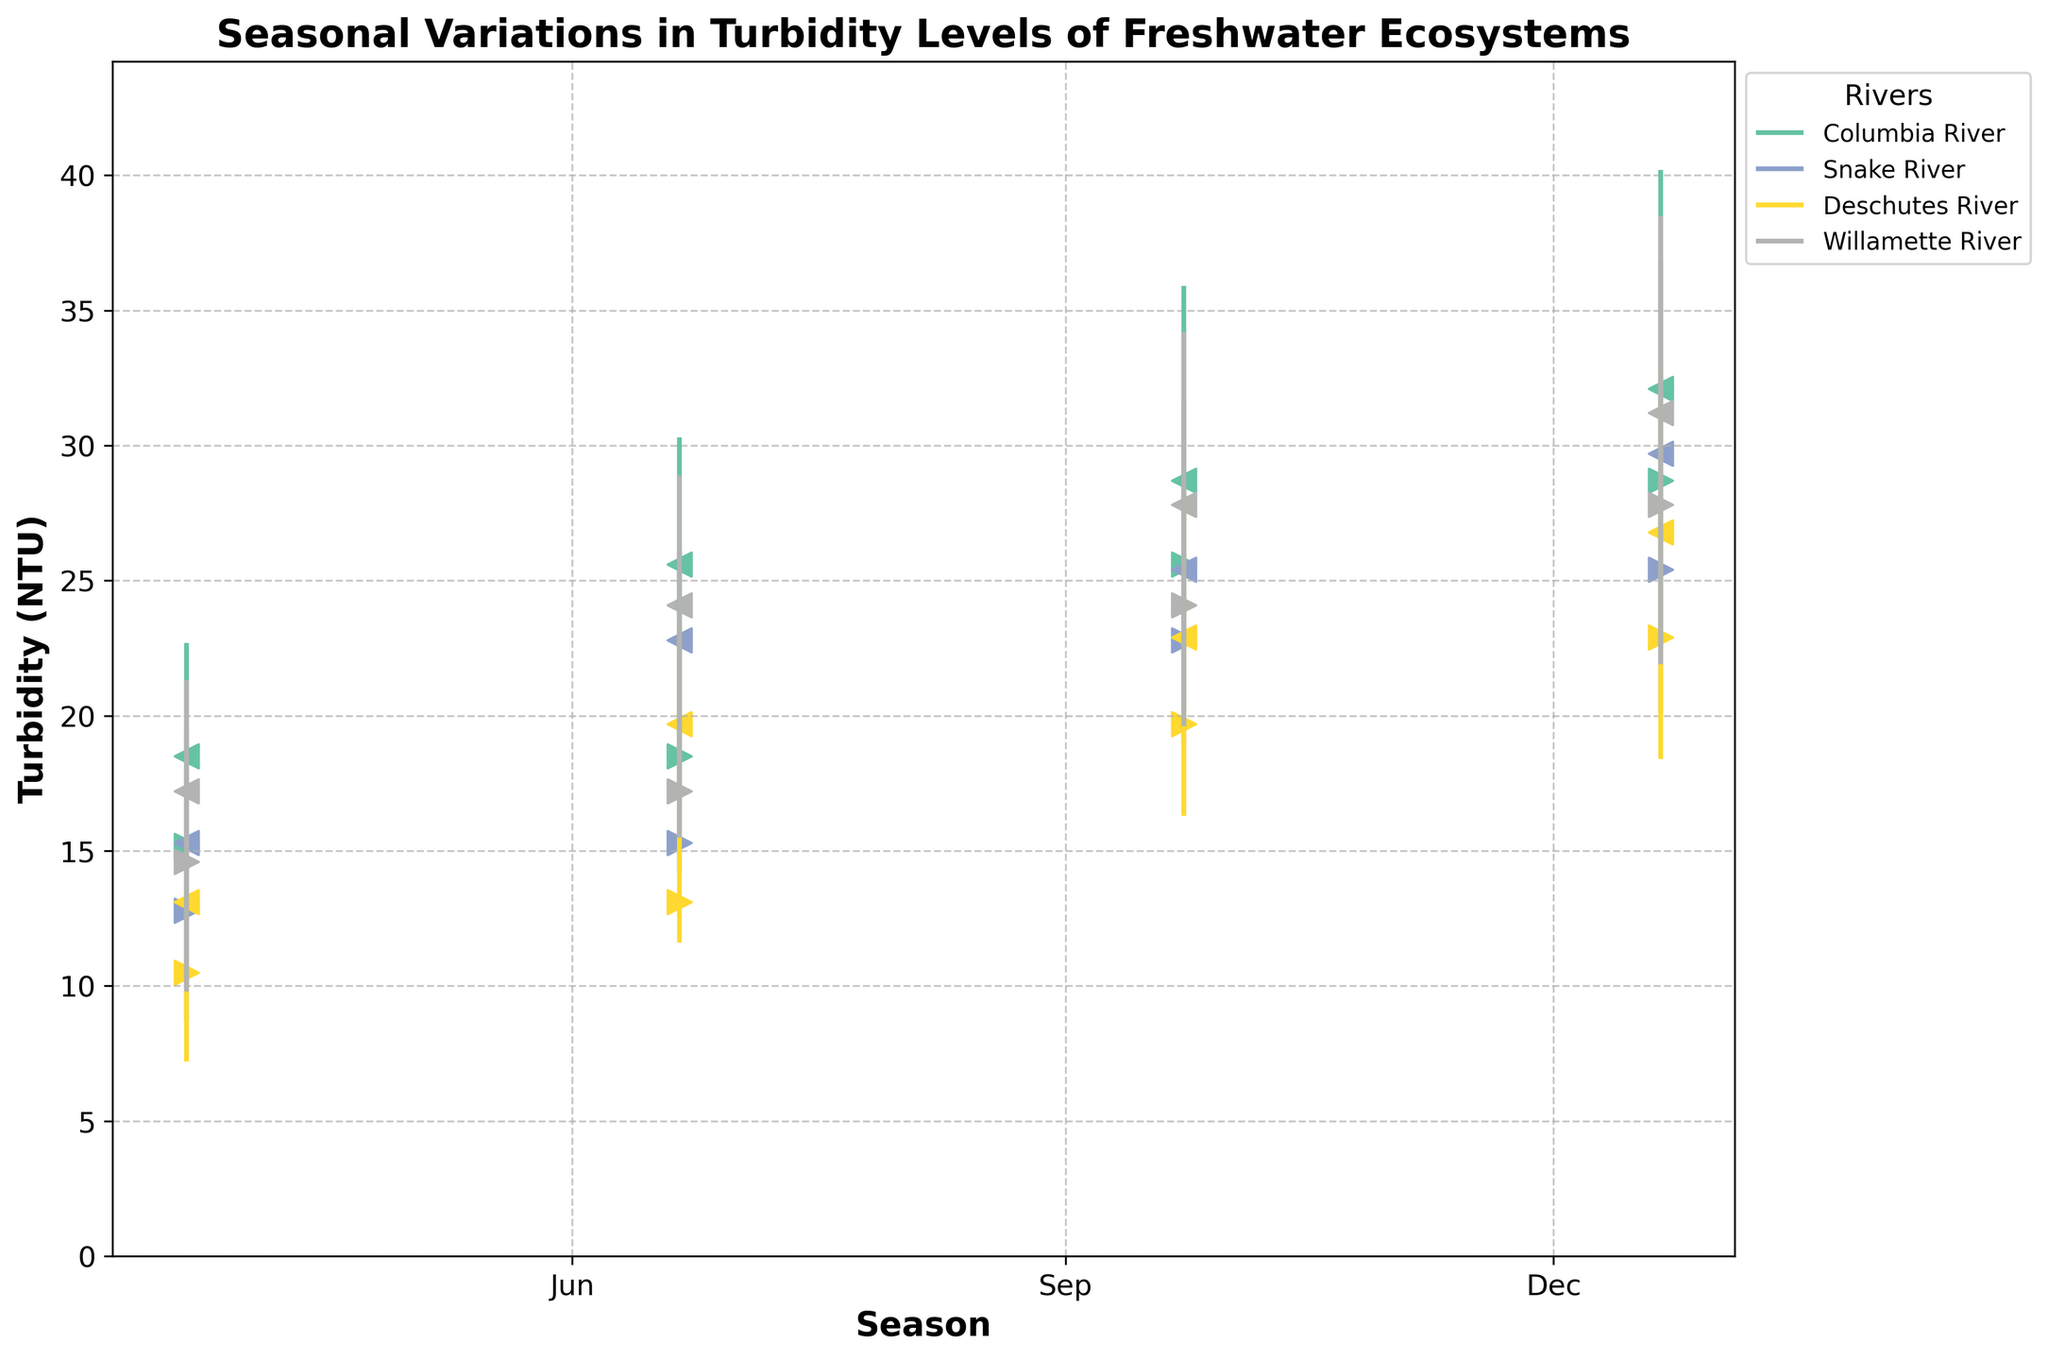What is the title of the figure? The title is displayed at the top of the figure and it is "Seasonal Variations in Turbidity Levels of Freshwater Ecosystems".
Answer: Seasonal Variations in Turbidity Levels of Freshwater Ecosystems How many rivers are represented in the plot? By looking at the legend, we can see the different colors and labels for each river. The figure shows four rivers: Columbia River, Snake River, Deschutes River, and Willamette River.
Answer: Four Which river has the highest turbidity level in the winter season? To identify the river with the highest turbidity level in winter, we observe the 'High' values for each river in the winter season. The Columbia River has the highest value at 40.2 NTU.
Answer: Columbia River What is the range of turbidity levels for the Snake River in summer? The range can be calculated by subtracting the lowest value ('Low') from the highest value ('High') for the Snake River in the summer season. The values are 26.1 (High) and 14.2 (Low), so the range is 26.1 - 14.2 = 11.9 NTU.
Answer: 11.9 NTU How does the turbidity level in the Deschutes River change from spring to summer? To understand the change, we compare the 'Close' value in spring with the 'Open' value in summer for Deschutes River. The turbidity level closed at 13.1 NTU in spring and opened at 13.1 NTU in summer, indicating no change.
Answer: No change In which season does the Willamette River have the lowest turbidity level recorded? We need to find the lowest 'Low' values for the Willamette River across all seasons. The lowest value recorded is 9.8 NTU in the spring season.
Answer: Spring How much higher is the Columbia River's turbidity peak in winter compared to fall? To calculate the difference, subtract the 'High' value of fall from that of winter for the Columbia River. The 'High' values are 40.2 (winter) and 35.9 (fall), so the difference is 40.2 - 35.9 = 4.3 NTU.
Answer: 4.3 NTU Which river shows the smallest variation in turbidity levels during the summer? To find the smallest variation, we look for the smallest difference between the 'High' and 'Low' values for each river in summer. Deschutes River has the smallest range with 23.4 - 11.6 = 11.8 NTU.
Answer: Deschutes River What is the average turbidity level for the Willamette River in fall, considering the open and close values? To find the average, add the 'Open' and 'Close' values for the Willamette River in fall and divide by 2. The values are 24.1 (open) and 27.8 (close), so the average is (24.1 + 27.8) / 2 = 25.95 NTU.
Answer: 25.95 NTU Which river shows an increasing trend in turbidity levels from spring to winter? We need to compare the 'Close' values of each season and check for an increasing pattern from spring to winter. The Columbia River shows an increasing trend with values: 18.5 (spring), 25.6 (summer), 28.7 (fall), 32.1 (winter).
Answer: Columbia River 